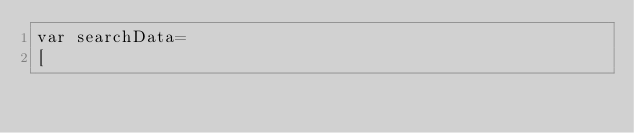<code> <loc_0><loc_0><loc_500><loc_500><_JavaScript_>var searchData=
[</code> 